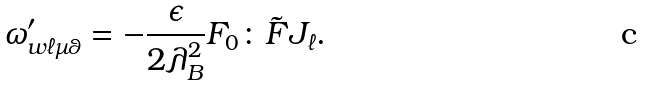Convert formula to latex. <formula><loc_0><loc_0><loc_500><loc_500>\omega ^ { \prime } _ { w \ell \mu \theta } = - \frac { \epsilon } { 2 \lambda _ { B } ^ { 2 } } F _ { 0 } \colon \tilde { F } J _ { \ell } .</formula> 